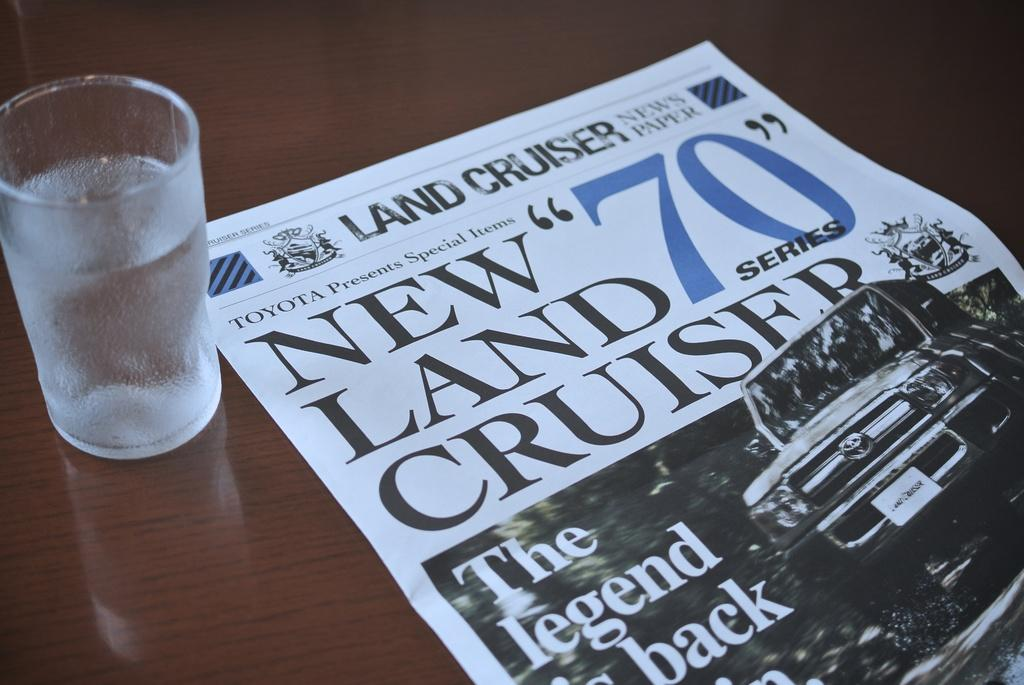<image>
Offer a succinct explanation of the picture presented. A glass of water and a land cruiser newspaper next to it. 